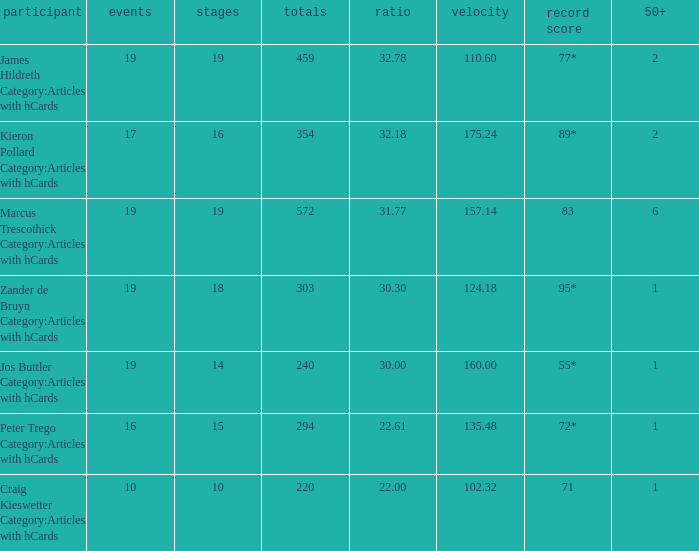I'm looking to parse the entire table for insights. Could you assist me with that? {'header': ['participant', 'events', 'stages', 'totals', 'ratio', 'velocity', 'record score', '50+'], 'rows': [['James Hildreth Category:Articles with hCards', '19', '19', '459', '32.78', '110.60', '77*', '2'], ['Kieron Pollard Category:Articles with hCards', '17', '16', '354', '32.18', '175.24', '89*', '2'], ['Marcus Trescothick Category:Articles with hCards', '19', '19', '572', '31.77', '157.14', '83', '6'], ['Zander de Bruyn Category:Articles with hCards', '19', '18', '303', '30.30', '124.18', '95*', '1'], ['Jos Buttler Category:Articles with hCards', '19', '14', '240', '30.00', '160.00', '55*', '1'], ['Peter Trego Category:Articles with hCards', '16', '15', '294', '22.61', '135.48', '72*', '1'], ['Craig Kieswetter Category:Articles with hCards', '10', '10', '220', '22.00', '102.32', '71', '1']]} What is the highest score for the player with average of 30.00? 55*. 